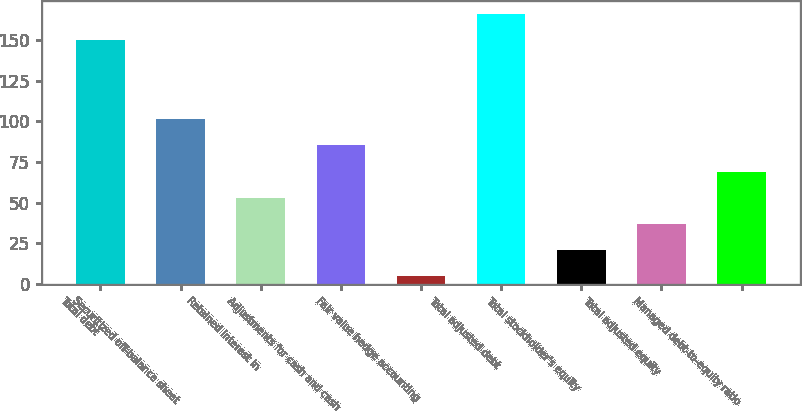Convert chart. <chart><loc_0><loc_0><loc_500><loc_500><bar_chart><fcel>Total debt<fcel>Securitized off-balance sheet<fcel>Retained interest in<fcel>Adjustments for cash and cash<fcel>Fair value hedge accounting<fcel>Total adjusted debt<fcel>Total stockholder's equity<fcel>Total adjusted equity<fcel>Managed debt-to-equity ratio<nl><fcel>149.7<fcel>101.3<fcel>53<fcel>85.2<fcel>4.7<fcel>165.8<fcel>20.8<fcel>36.9<fcel>69.1<nl></chart> 